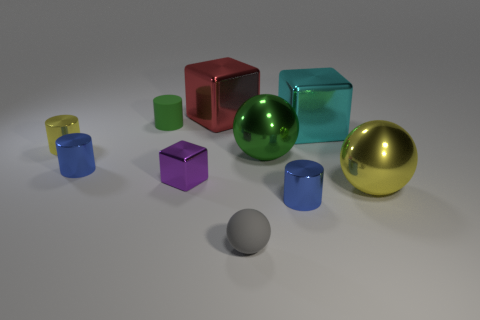Is there a tiny cylinder of the same color as the rubber ball? no 